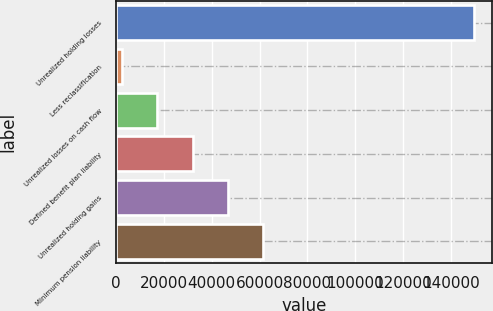Convert chart. <chart><loc_0><loc_0><loc_500><loc_500><bar_chart><fcel>Unrealized holding losses<fcel>Less reclassification<fcel>Unrealized losses on cash flow<fcel>Defined benefit plan liability<fcel>Unrealized holding gains<fcel>Minimum pension liability<nl><fcel>149854<fcel>2566<fcel>17294.8<fcel>32023.6<fcel>46752.4<fcel>61481.2<nl></chart> 